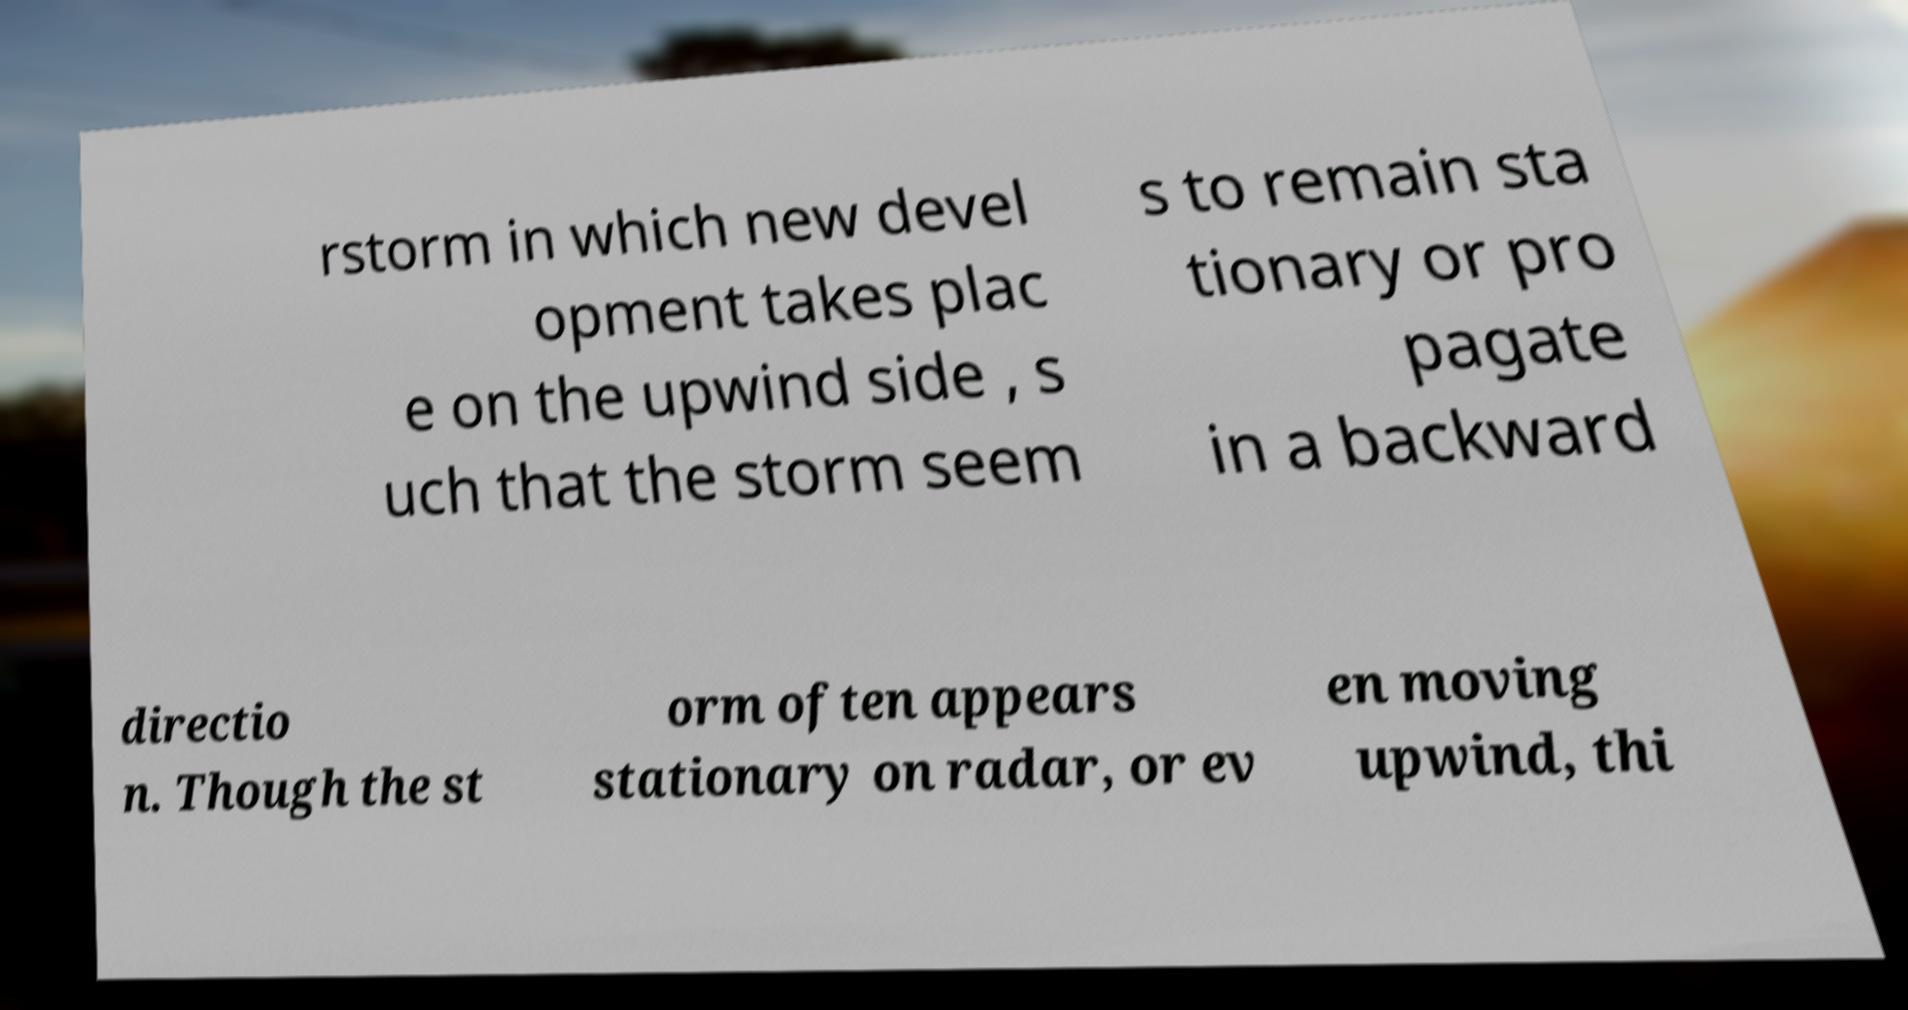What messages or text are displayed in this image? I need them in a readable, typed format. rstorm in which new devel opment takes plac e on the upwind side , s uch that the storm seem s to remain sta tionary or pro pagate in a backward directio n. Though the st orm often appears stationary on radar, or ev en moving upwind, thi 